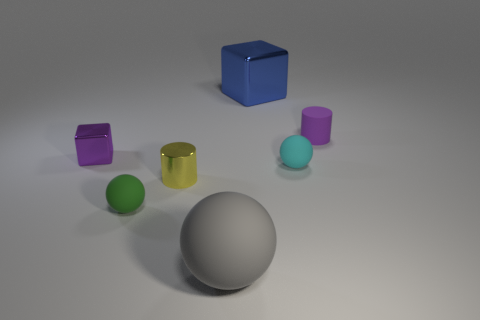Add 2 tiny objects. How many objects exist? 9 Subtract all blocks. How many objects are left? 5 Subtract all small cyan matte things. Subtract all large matte things. How many objects are left? 5 Add 6 tiny cyan rubber objects. How many tiny cyan rubber objects are left? 7 Add 5 small yellow matte cylinders. How many small yellow matte cylinders exist? 5 Subtract 0 purple spheres. How many objects are left? 7 